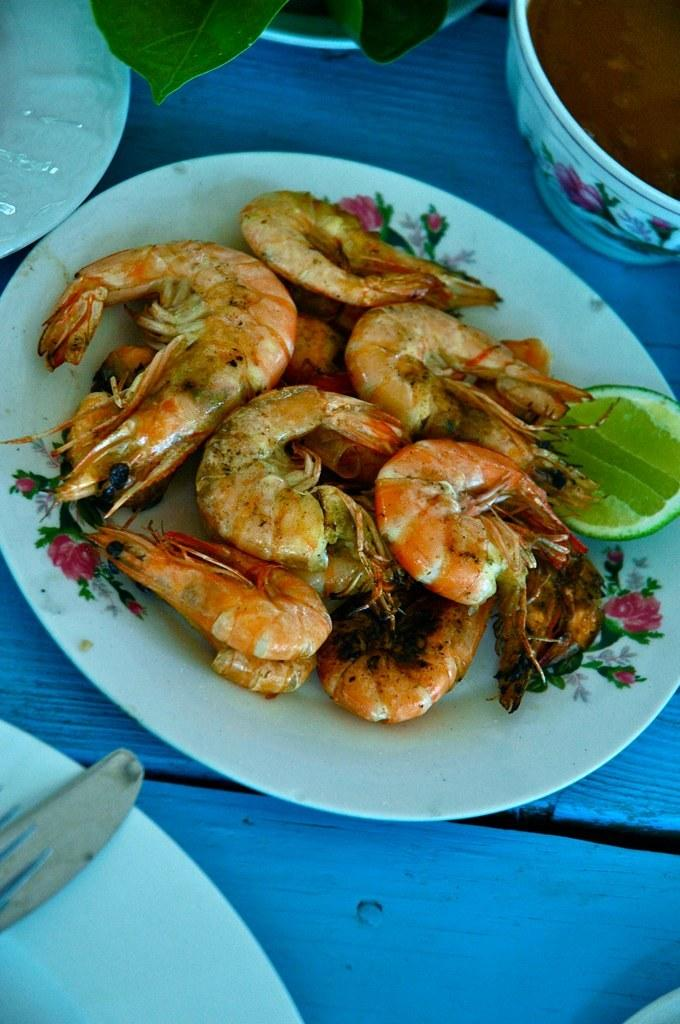What type of items can be seen in the image? The image contains food and white plates. Can you describe the utensil on the plate? There is a spoon on the plate. What can be seen at the top of the image? Leaves are visible at the top of the image. What direction is the kettle facing in the image? There is no kettle present in the image. Can you describe the scent of the food in the image? The image is a visual representation, so it does not convey the scent of the food. 